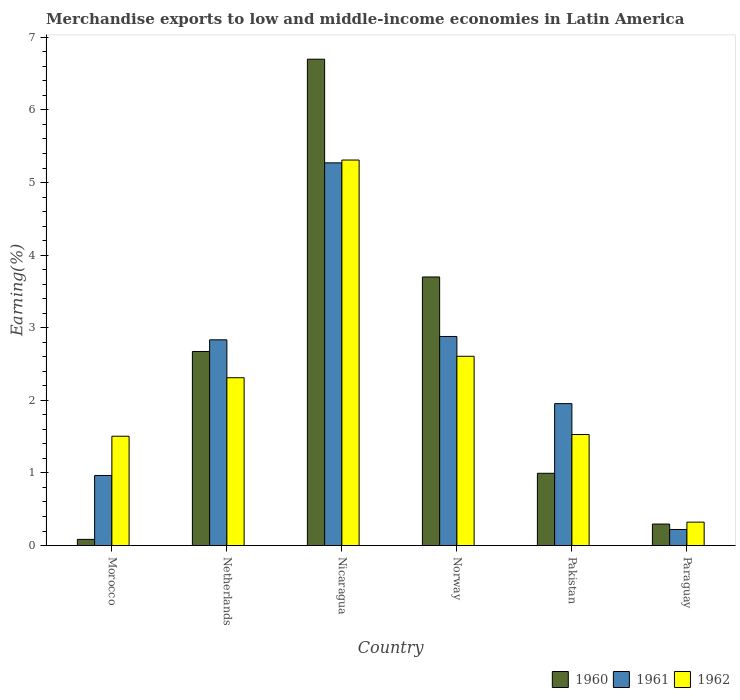How many different coloured bars are there?
Ensure brevity in your answer.  3. Are the number of bars per tick equal to the number of legend labels?
Make the answer very short. Yes. How many bars are there on the 4th tick from the right?
Your answer should be compact. 3. What is the label of the 3rd group of bars from the left?
Your answer should be compact. Nicaragua. In how many cases, is the number of bars for a given country not equal to the number of legend labels?
Make the answer very short. 0. What is the percentage of amount earned from merchandise exports in 1960 in Paraguay?
Make the answer very short. 0.3. Across all countries, what is the maximum percentage of amount earned from merchandise exports in 1960?
Your answer should be compact. 6.7. Across all countries, what is the minimum percentage of amount earned from merchandise exports in 1962?
Ensure brevity in your answer.  0.32. In which country was the percentage of amount earned from merchandise exports in 1961 maximum?
Ensure brevity in your answer.  Nicaragua. In which country was the percentage of amount earned from merchandise exports in 1960 minimum?
Your answer should be compact. Morocco. What is the total percentage of amount earned from merchandise exports in 1960 in the graph?
Ensure brevity in your answer.  14.45. What is the difference between the percentage of amount earned from merchandise exports in 1962 in Netherlands and that in Paraguay?
Provide a short and direct response. 1.99. What is the difference between the percentage of amount earned from merchandise exports in 1961 in Norway and the percentage of amount earned from merchandise exports in 1962 in Nicaragua?
Offer a terse response. -2.43. What is the average percentage of amount earned from merchandise exports in 1961 per country?
Your answer should be very brief. 2.35. What is the difference between the percentage of amount earned from merchandise exports of/in 1960 and percentage of amount earned from merchandise exports of/in 1962 in Netherlands?
Provide a short and direct response. 0.36. What is the ratio of the percentage of amount earned from merchandise exports in 1962 in Norway to that in Pakistan?
Make the answer very short. 1.7. Is the difference between the percentage of amount earned from merchandise exports in 1960 in Norway and Pakistan greater than the difference between the percentage of amount earned from merchandise exports in 1962 in Norway and Pakistan?
Your answer should be very brief. Yes. What is the difference between the highest and the second highest percentage of amount earned from merchandise exports in 1962?
Your answer should be very brief. 0.3. What is the difference between the highest and the lowest percentage of amount earned from merchandise exports in 1962?
Your answer should be compact. 4.99. In how many countries, is the percentage of amount earned from merchandise exports in 1960 greater than the average percentage of amount earned from merchandise exports in 1960 taken over all countries?
Provide a succinct answer. 3. What does the 3rd bar from the left in Netherlands represents?
Give a very brief answer. 1962. What does the 1st bar from the right in Netherlands represents?
Make the answer very short. 1962. Is it the case that in every country, the sum of the percentage of amount earned from merchandise exports in 1962 and percentage of amount earned from merchandise exports in 1960 is greater than the percentage of amount earned from merchandise exports in 1961?
Your answer should be very brief. Yes. How many bars are there?
Offer a very short reply. 18. Are the values on the major ticks of Y-axis written in scientific E-notation?
Keep it short and to the point. No. Does the graph contain any zero values?
Make the answer very short. No. Where does the legend appear in the graph?
Offer a very short reply. Bottom right. What is the title of the graph?
Keep it short and to the point. Merchandise exports to low and middle-income economies in Latin America. Does "1972" appear as one of the legend labels in the graph?
Provide a short and direct response. No. What is the label or title of the Y-axis?
Make the answer very short. Earning(%). What is the Earning(%) in 1960 in Morocco?
Make the answer very short. 0.09. What is the Earning(%) in 1961 in Morocco?
Offer a terse response. 0.97. What is the Earning(%) of 1962 in Morocco?
Make the answer very short. 1.51. What is the Earning(%) in 1960 in Netherlands?
Ensure brevity in your answer.  2.67. What is the Earning(%) in 1961 in Netherlands?
Offer a terse response. 2.83. What is the Earning(%) of 1962 in Netherlands?
Make the answer very short. 2.31. What is the Earning(%) in 1960 in Nicaragua?
Your answer should be compact. 6.7. What is the Earning(%) in 1961 in Nicaragua?
Provide a succinct answer. 5.27. What is the Earning(%) in 1962 in Nicaragua?
Keep it short and to the point. 5.31. What is the Earning(%) in 1960 in Norway?
Offer a terse response. 3.7. What is the Earning(%) of 1961 in Norway?
Your answer should be compact. 2.88. What is the Earning(%) of 1962 in Norway?
Your response must be concise. 2.61. What is the Earning(%) in 1960 in Pakistan?
Ensure brevity in your answer.  1. What is the Earning(%) in 1961 in Pakistan?
Provide a short and direct response. 1.95. What is the Earning(%) of 1962 in Pakistan?
Provide a succinct answer. 1.53. What is the Earning(%) in 1960 in Paraguay?
Your answer should be very brief. 0.3. What is the Earning(%) of 1961 in Paraguay?
Give a very brief answer. 0.22. What is the Earning(%) of 1962 in Paraguay?
Make the answer very short. 0.32. Across all countries, what is the maximum Earning(%) in 1960?
Give a very brief answer. 6.7. Across all countries, what is the maximum Earning(%) of 1961?
Make the answer very short. 5.27. Across all countries, what is the maximum Earning(%) of 1962?
Your answer should be compact. 5.31. Across all countries, what is the minimum Earning(%) of 1960?
Offer a terse response. 0.09. Across all countries, what is the minimum Earning(%) in 1961?
Your answer should be very brief. 0.22. Across all countries, what is the minimum Earning(%) of 1962?
Keep it short and to the point. 0.32. What is the total Earning(%) in 1960 in the graph?
Provide a short and direct response. 14.45. What is the total Earning(%) in 1961 in the graph?
Provide a succinct answer. 14.13. What is the total Earning(%) in 1962 in the graph?
Offer a terse response. 13.59. What is the difference between the Earning(%) in 1960 in Morocco and that in Netherlands?
Your response must be concise. -2.59. What is the difference between the Earning(%) of 1961 in Morocco and that in Netherlands?
Your answer should be very brief. -1.87. What is the difference between the Earning(%) of 1962 in Morocco and that in Netherlands?
Your answer should be very brief. -0.81. What is the difference between the Earning(%) of 1960 in Morocco and that in Nicaragua?
Keep it short and to the point. -6.61. What is the difference between the Earning(%) of 1961 in Morocco and that in Nicaragua?
Your answer should be very brief. -4.31. What is the difference between the Earning(%) of 1962 in Morocco and that in Nicaragua?
Your response must be concise. -3.8. What is the difference between the Earning(%) in 1960 in Morocco and that in Norway?
Your response must be concise. -3.61. What is the difference between the Earning(%) in 1961 in Morocco and that in Norway?
Ensure brevity in your answer.  -1.91. What is the difference between the Earning(%) of 1962 in Morocco and that in Norway?
Offer a very short reply. -1.1. What is the difference between the Earning(%) of 1960 in Morocco and that in Pakistan?
Provide a short and direct response. -0.91. What is the difference between the Earning(%) of 1961 in Morocco and that in Pakistan?
Provide a short and direct response. -0.99. What is the difference between the Earning(%) of 1962 in Morocco and that in Pakistan?
Provide a short and direct response. -0.02. What is the difference between the Earning(%) in 1960 in Morocco and that in Paraguay?
Provide a succinct answer. -0.21. What is the difference between the Earning(%) in 1961 in Morocco and that in Paraguay?
Provide a succinct answer. 0.74. What is the difference between the Earning(%) in 1962 in Morocco and that in Paraguay?
Offer a very short reply. 1.18. What is the difference between the Earning(%) in 1960 in Netherlands and that in Nicaragua?
Your answer should be compact. -4.03. What is the difference between the Earning(%) in 1961 in Netherlands and that in Nicaragua?
Your answer should be compact. -2.44. What is the difference between the Earning(%) of 1962 in Netherlands and that in Nicaragua?
Give a very brief answer. -3. What is the difference between the Earning(%) of 1960 in Netherlands and that in Norway?
Offer a terse response. -1.03. What is the difference between the Earning(%) of 1961 in Netherlands and that in Norway?
Your response must be concise. -0.05. What is the difference between the Earning(%) in 1962 in Netherlands and that in Norway?
Provide a succinct answer. -0.3. What is the difference between the Earning(%) of 1960 in Netherlands and that in Pakistan?
Keep it short and to the point. 1.68. What is the difference between the Earning(%) of 1961 in Netherlands and that in Pakistan?
Your answer should be compact. 0.88. What is the difference between the Earning(%) of 1962 in Netherlands and that in Pakistan?
Keep it short and to the point. 0.78. What is the difference between the Earning(%) in 1960 in Netherlands and that in Paraguay?
Offer a terse response. 2.38. What is the difference between the Earning(%) of 1961 in Netherlands and that in Paraguay?
Make the answer very short. 2.61. What is the difference between the Earning(%) in 1962 in Netherlands and that in Paraguay?
Provide a succinct answer. 1.99. What is the difference between the Earning(%) in 1960 in Nicaragua and that in Norway?
Give a very brief answer. 3. What is the difference between the Earning(%) of 1961 in Nicaragua and that in Norway?
Offer a terse response. 2.39. What is the difference between the Earning(%) in 1962 in Nicaragua and that in Norway?
Give a very brief answer. 2.7. What is the difference between the Earning(%) in 1960 in Nicaragua and that in Pakistan?
Make the answer very short. 5.7. What is the difference between the Earning(%) in 1961 in Nicaragua and that in Pakistan?
Make the answer very short. 3.32. What is the difference between the Earning(%) in 1962 in Nicaragua and that in Pakistan?
Your answer should be very brief. 3.78. What is the difference between the Earning(%) of 1960 in Nicaragua and that in Paraguay?
Offer a very short reply. 6.4. What is the difference between the Earning(%) of 1961 in Nicaragua and that in Paraguay?
Your answer should be compact. 5.05. What is the difference between the Earning(%) in 1962 in Nicaragua and that in Paraguay?
Your answer should be compact. 4.99. What is the difference between the Earning(%) of 1960 in Norway and that in Pakistan?
Make the answer very short. 2.7. What is the difference between the Earning(%) in 1961 in Norway and that in Pakistan?
Your answer should be compact. 0.92. What is the difference between the Earning(%) in 1962 in Norway and that in Pakistan?
Your response must be concise. 1.08. What is the difference between the Earning(%) in 1960 in Norway and that in Paraguay?
Your answer should be compact. 3.4. What is the difference between the Earning(%) in 1961 in Norway and that in Paraguay?
Keep it short and to the point. 2.66. What is the difference between the Earning(%) in 1962 in Norway and that in Paraguay?
Your answer should be very brief. 2.28. What is the difference between the Earning(%) in 1960 in Pakistan and that in Paraguay?
Offer a terse response. 0.7. What is the difference between the Earning(%) in 1961 in Pakistan and that in Paraguay?
Your answer should be compact. 1.73. What is the difference between the Earning(%) of 1962 in Pakistan and that in Paraguay?
Your response must be concise. 1.21. What is the difference between the Earning(%) in 1960 in Morocco and the Earning(%) in 1961 in Netherlands?
Your response must be concise. -2.75. What is the difference between the Earning(%) in 1960 in Morocco and the Earning(%) in 1962 in Netherlands?
Your answer should be compact. -2.23. What is the difference between the Earning(%) of 1961 in Morocco and the Earning(%) of 1962 in Netherlands?
Your answer should be compact. -1.35. What is the difference between the Earning(%) in 1960 in Morocco and the Earning(%) in 1961 in Nicaragua?
Provide a succinct answer. -5.19. What is the difference between the Earning(%) of 1960 in Morocco and the Earning(%) of 1962 in Nicaragua?
Keep it short and to the point. -5.22. What is the difference between the Earning(%) in 1961 in Morocco and the Earning(%) in 1962 in Nicaragua?
Provide a short and direct response. -4.34. What is the difference between the Earning(%) of 1960 in Morocco and the Earning(%) of 1961 in Norway?
Your response must be concise. -2.79. What is the difference between the Earning(%) of 1960 in Morocco and the Earning(%) of 1962 in Norway?
Make the answer very short. -2.52. What is the difference between the Earning(%) in 1961 in Morocco and the Earning(%) in 1962 in Norway?
Keep it short and to the point. -1.64. What is the difference between the Earning(%) in 1960 in Morocco and the Earning(%) in 1961 in Pakistan?
Your answer should be compact. -1.87. What is the difference between the Earning(%) of 1960 in Morocco and the Earning(%) of 1962 in Pakistan?
Give a very brief answer. -1.44. What is the difference between the Earning(%) of 1961 in Morocco and the Earning(%) of 1962 in Pakistan?
Keep it short and to the point. -0.56. What is the difference between the Earning(%) of 1960 in Morocco and the Earning(%) of 1961 in Paraguay?
Ensure brevity in your answer.  -0.14. What is the difference between the Earning(%) of 1960 in Morocco and the Earning(%) of 1962 in Paraguay?
Provide a succinct answer. -0.24. What is the difference between the Earning(%) in 1961 in Morocco and the Earning(%) in 1962 in Paraguay?
Your answer should be very brief. 0.64. What is the difference between the Earning(%) of 1960 in Netherlands and the Earning(%) of 1961 in Nicaragua?
Ensure brevity in your answer.  -2.6. What is the difference between the Earning(%) of 1960 in Netherlands and the Earning(%) of 1962 in Nicaragua?
Provide a short and direct response. -2.64. What is the difference between the Earning(%) in 1961 in Netherlands and the Earning(%) in 1962 in Nicaragua?
Your answer should be compact. -2.48. What is the difference between the Earning(%) in 1960 in Netherlands and the Earning(%) in 1961 in Norway?
Keep it short and to the point. -0.21. What is the difference between the Earning(%) of 1960 in Netherlands and the Earning(%) of 1962 in Norway?
Offer a terse response. 0.07. What is the difference between the Earning(%) in 1961 in Netherlands and the Earning(%) in 1962 in Norway?
Your answer should be compact. 0.23. What is the difference between the Earning(%) of 1960 in Netherlands and the Earning(%) of 1961 in Pakistan?
Make the answer very short. 0.72. What is the difference between the Earning(%) of 1960 in Netherlands and the Earning(%) of 1962 in Pakistan?
Your response must be concise. 1.14. What is the difference between the Earning(%) in 1961 in Netherlands and the Earning(%) in 1962 in Pakistan?
Make the answer very short. 1.3. What is the difference between the Earning(%) of 1960 in Netherlands and the Earning(%) of 1961 in Paraguay?
Provide a short and direct response. 2.45. What is the difference between the Earning(%) of 1960 in Netherlands and the Earning(%) of 1962 in Paraguay?
Keep it short and to the point. 2.35. What is the difference between the Earning(%) of 1961 in Netherlands and the Earning(%) of 1962 in Paraguay?
Provide a short and direct response. 2.51. What is the difference between the Earning(%) in 1960 in Nicaragua and the Earning(%) in 1961 in Norway?
Your answer should be very brief. 3.82. What is the difference between the Earning(%) in 1960 in Nicaragua and the Earning(%) in 1962 in Norway?
Give a very brief answer. 4.09. What is the difference between the Earning(%) of 1961 in Nicaragua and the Earning(%) of 1962 in Norway?
Offer a terse response. 2.66. What is the difference between the Earning(%) in 1960 in Nicaragua and the Earning(%) in 1961 in Pakistan?
Your response must be concise. 4.74. What is the difference between the Earning(%) in 1960 in Nicaragua and the Earning(%) in 1962 in Pakistan?
Offer a very short reply. 5.17. What is the difference between the Earning(%) of 1961 in Nicaragua and the Earning(%) of 1962 in Pakistan?
Make the answer very short. 3.74. What is the difference between the Earning(%) of 1960 in Nicaragua and the Earning(%) of 1961 in Paraguay?
Your response must be concise. 6.48. What is the difference between the Earning(%) of 1960 in Nicaragua and the Earning(%) of 1962 in Paraguay?
Keep it short and to the point. 6.38. What is the difference between the Earning(%) in 1961 in Nicaragua and the Earning(%) in 1962 in Paraguay?
Offer a very short reply. 4.95. What is the difference between the Earning(%) of 1960 in Norway and the Earning(%) of 1961 in Pakistan?
Your answer should be compact. 1.74. What is the difference between the Earning(%) of 1960 in Norway and the Earning(%) of 1962 in Pakistan?
Offer a terse response. 2.17. What is the difference between the Earning(%) of 1961 in Norway and the Earning(%) of 1962 in Pakistan?
Your answer should be compact. 1.35. What is the difference between the Earning(%) of 1960 in Norway and the Earning(%) of 1961 in Paraguay?
Make the answer very short. 3.48. What is the difference between the Earning(%) of 1960 in Norway and the Earning(%) of 1962 in Paraguay?
Your answer should be compact. 3.38. What is the difference between the Earning(%) in 1961 in Norway and the Earning(%) in 1962 in Paraguay?
Ensure brevity in your answer.  2.56. What is the difference between the Earning(%) of 1960 in Pakistan and the Earning(%) of 1961 in Paraguay?
Ensure brevity in your answer.  0.77. What is the difference between the Earning(%) in 1960 in Pakistan and the Earning(%) in 1962 in Paraguay?
Ensure brevity in your answer.  0.67. What is the difference between the Earning(%) in 1961 in Pakistan and the Earning(%) in 1962 in Paraguay?
Provide a succinct answer. 1.63. What is the average Earning(%) of 1960 per country?
Offer a very short reply. 2.41. What is the average Earning(%) of 1961 per country?
Your response must be concise. 2.35. What is the average Earning(%) of 1962 per country?
Your answer should be very brief. 2.26. What is the difference between the Earning(%) in 1960 and Earning(%) in 1961 in Morocco?
Your response must be concise. -0.88. What is the difference between the Earning(%) of 1960 and Earning(%) of 1962 in Morocco?
Your answer should be very brief. -1.42. What is the difference between the Earning(%) in 1961 and Earning(%) in 1962 in Morocco?
Provide a short and direct response. -0.54. What is the difference between the Earning(%) of 1960 and Earning(%) of 1961 in Netherlands?
Keep it short and to the point. -0.16. What is the difference between the Earning(%) in 1960 and Earning(%) in 1962 in Netherlands?
Offer a terse response. 0.36. What is the difference between the Earning(%) of 1961 and Earning(%) of 1962 in Netherlands?
Give a very brief answer. 0.52. What is the difference between the Earning(%) in 1960 and Earning(%) in 1961 in Nicaragua?
Make the answer very short. 1.43. What is the difference between the Earning(%) of 1960 and Earning(%) of 1962 in Nicaragua?
Ensure brevity in your answer.  1.39. What is the difference between the Earning(%) of 1961 and Earning(%) of 1962 in Nicaragua?
Your answer should be very brief. -0.04. What is the difference between the Earning(%) in 1960 and Earning(%) in 1961 in Norway?
Offer a very short reply. 0.82. What is the difference between the Earning(%) in 1960 and Earning(%) in 1962 in Norway?
Provide a short and direct response. 1.09. What is the difference between the Earning(%) in 1961 and Earning(%) in 1962 in Norway?
Provide a short and direct response. 0.27. What is the difference between the Earning(%) of 1960 and Earning(%) of 1961 in Pakistan?
Provide a succinct answer. -0.96. What is the difference between the Earning(%) of 1960 and Earning(%) of 1962 in Pakistan?
Your answer should be very brief. -0.53. What is the difference between the Earning(%) of 1961 and Earning(%) of 1962 in Pakistan?
Your answer should be very brief. 0.43. What is the difference between the Earning(%) in 1960 and Earning(%) in 1961 in Paraguay?
Ensure brevity in your answer.  0.07. What is the difference between the Earning(%) of 1960 and Earning(%) of 1962 in Paraguay?
Your answer should be very brief. -0.03. What is the difference between the Earning(%) in 1961 and Earning(%) in 1962 in Paraguay?
Offer a very short reply. -0.1. What is the ratio of the Earning(%) of 1960 in Morocco to that in Netherlands?
Your answer should be compact. 0.03. What is the ratio of the Earning(%) of 1961 in Morocco to that in Netherlands?
Your answer should be compact. 0.34. What is the ratio of the Earning(%) in 1962 in Morocco to that in Netherlands?
Keep it short and to the point. 0.65. What is the ratio of the Earning(%) in 1960 in Morocco to that in Nicaragua?
Make the answer very short. 0.01. What is the ratio of the Earning(%) of 1961 in Morocco to that in Nicaragua?
Your answer should be very brief. 0.18. What is the ratio of the Earning(%) of 1962 in Morocco to that in Nicaragua?
Give a very brief answer. 0.28. What is the ratio of the Earning(%) of 1960 in Morocco to that in Norway?
Your answer should be very brief. 0.02. What is the ratio of the Earning(%) of 1961 in Morocco to that in Norway?
Your answer should be compact. 0.34. What is the ratio of the Earning(%) of 1962 in Morocco to that in Norway?
Provide a succinct answer. 0.58. What is the ratio of the Earning(%) in 1960 in Morocco to that in Pakistan?
Make the answer very short. 0.09. What is the ratio of the Earning(%) of 1961 in Morocco to that in Pakistan?
Provide a succinct answer. 0.49. What is the ratio of the Earning(%) in 1962 in Morocco to that in Pakistan?
Provide a short and direct response. 0.98. What is the ratio of the Earning(%) in 1960 in Morocco to that in Paraguay?
Provide a succinct answer. 0.29. What is the ratio of the Earning(%) of 1961 in Morocco to that in Paraguay?
Your answer should be compact. 4.35. What is the ratio of the Earning(%) in 1962 in Morocco to that in Paraguay?
Keep it short and to the point. 4.67. What is the ratio of the Earning(%) in 1960 in Netherlands to that in Nicaragua?
Provide a succinct answer. 0.4. What is the ratio of the Earning(%) in 1961 in Netherlands to that in Nicaragua?
Ensure brevity in your answer.  0.54. What is the ratio of the Earning(%) of 1962 in Netherlands to that in Nicaragua?
Your answer should be compact. 0.44. What is the ratio of the Earning(%) in 1960 in Netherlands to that in Norway?
Offer a terse response. 0.72. What is the ratio of the Earning(%) of 1962 in Netherlands to that in Norway?
Your response must be concise. 0.89. What is the ratio of the Earning(%) of 1960 in Netherlands to that in Pakistan?
Offer a very short reply. 2.69. What is the ratio of the Earning(%) in 1961 in Netherlands to that in Pakistan?
Give a very brief answer. 1.45. What is the ratio of the Earning(%) in 1962 in Netherlands to that in Pakistan?
Make the answer very short. 1.51. What is the ratio of the Earning(%) in 1960 in Netherlands to that in Paraguay?
Your answer should be compact. 9.01. What is the ratio of the Earning(%) in 1961 in Netherlands to that in Paraguay?
Your answer should be compact. 12.78. What is the ratio of the Earning(%) in 1962 in Netherlands to that in Paraguay?
Offer a very short reply. 7.16. What is the ratio of the Earning(%) of 1960 in Nicaragua to that in Norway?
Keep it short and to the point. 1.81. What is the ratio of the Earning(%) of 1961 in Nicaragua to that in Norway?
Provide a short and direct response. 1.83. What is the ratio of the Earning(%) in 1962 in Nicaragua to that in Norway?
Keep it short and to the point. 2.04. What is the ratio of the Earning(%) of 1960 in Nicaragua to that in Pakistan?
Make the answer very short. 6.73. What is the ratio of the Earning(%) of 1961 in Nicaragua to that in Pakistan?
Your answer should be compact. 2.7. What is the ratio of the Earning(%) in 1962 in Nicaragua to that in Pakistan?
Your response must be concise. 3.47. What is the ratio of the Earning(%) in 1960 in Nicaragua to that in Paraguay?
Your response must be concise. 22.59. What is the ratio of the Earning(%) in 1961 in Nicaragua to that in Paraguay?
Offer a very short reply. 23.78. What is the ratio of the Earning(%) in 1962 in Nicaragua to that in Paraguay?
Your answer should be compact. 16.45. What is the ratio of the Earning(%) of 1960 in Norway to that in Pakistan?
Give a very brief answer. 3.72. What is the ratio of the Earning(%) in 1961 in Norway to that in Pakistan?
Your answer should be compact. 1.47. What is the ratio of the Earning(%) of 1962 in Norway to that in Pakistan?
Offer a very short reply. 1.7. What is the ratio of the Earning(%) in 1960 in Norway to that in Paraguay?
Give a very brief answer. 12.47. What is the ratio of the Earning(%) in 1961 in Norway to that in Paraguay?
Offer a very short reply. 12.99. What is the ratio of the Earning(%) of 1962 in Norway to that in Paraguay?
Provide a short and direct response. 8.08. What is the ratio of the Earning(%) of 1960 in Pakistan to that in Paraguay?
Ensure brevity in your answer.  3.36. What is the ratio of the Earning(%) in 1961 in Pakistan to that in Paraguay?
Offer a terse response. 8.82. What is the ratio of the Earning(%) of 1962 in Pakistan to that in Paraguay?
Your answer should be compact. 4.74. What is the difference between the highest and the second highest Earning(%) of 1960?
Ensure brevity in your answer.  3. What is the difference between the highest and the second highest Earning(%) of 1961?
Ensure brevity in your answer.  2.39. What is the difference between the highest and the second highest Earning(%) of 1962?
Your answer should be very brief. 2.7. What is the difference between the highest and the lowest Earning(%) of 1960?
Offer a very short reply. 6.61. What is the difference between the highest and the lowest Earning(%) in 1961?
Ensure brevity in your answer.  5.05. What is the difference between the highest and the lowest Earning(%) of 1962?
Offer a very short reply. 4.99. 